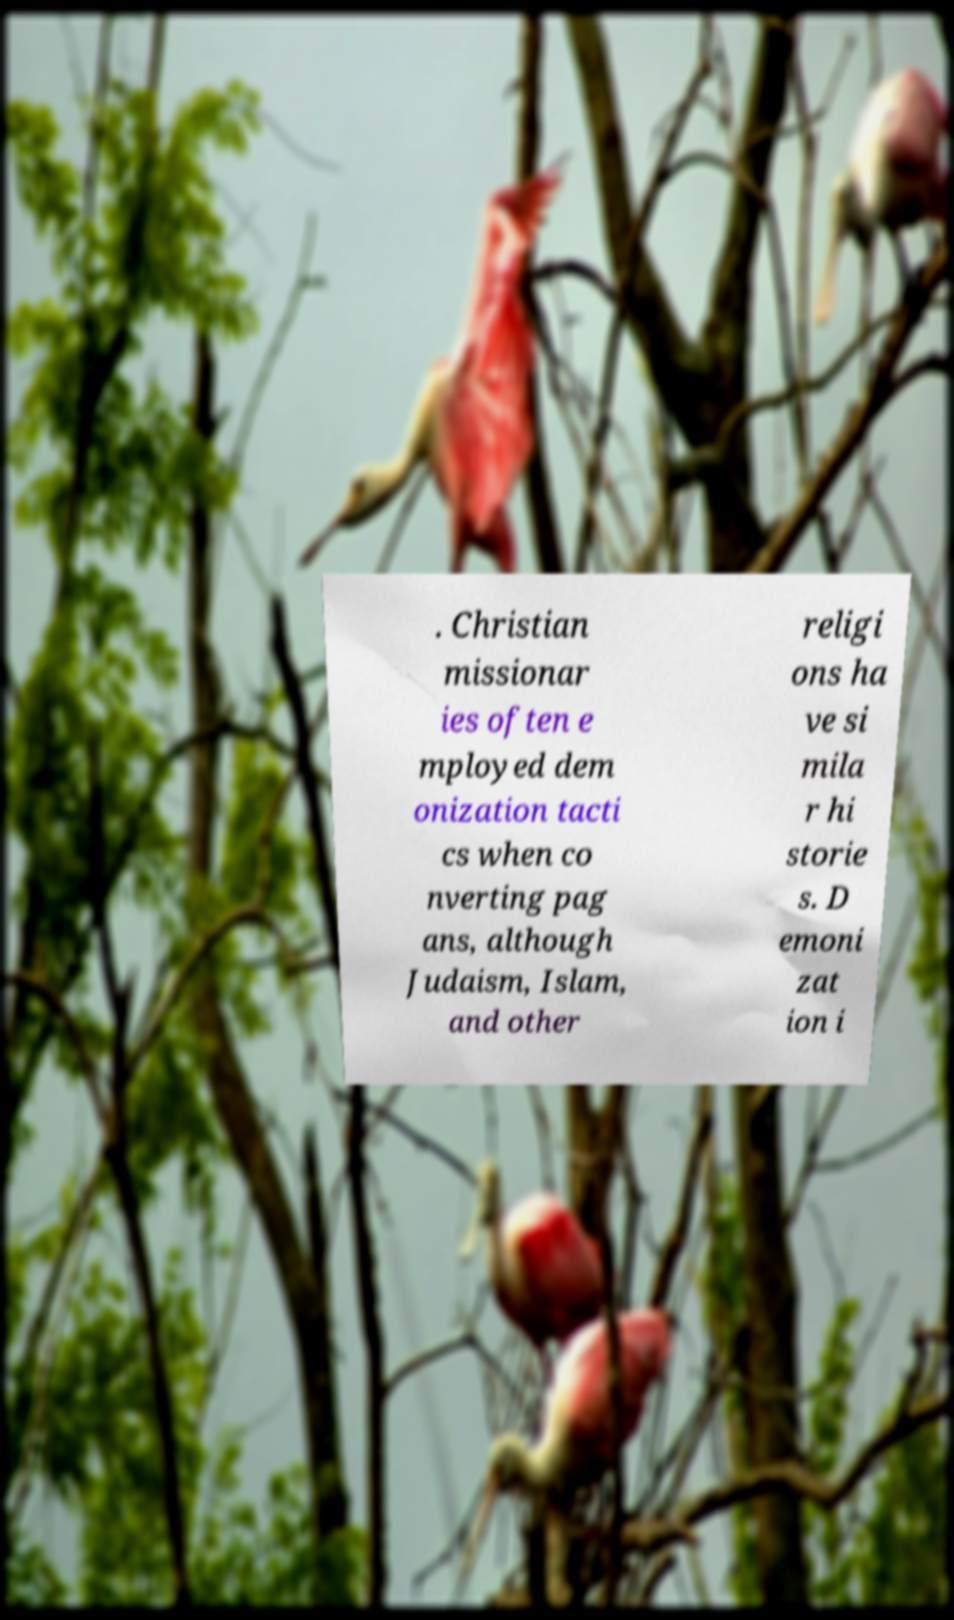For documentation purposes, I need the text within this image transcribed. Could you provide that? . Christian missionar ies often e mployed dem onization tacti cs when co nverting pag ans, although Judaism, Islam, and other religi ons ha ve si mila r hi storie s. D emoni zat ion i 